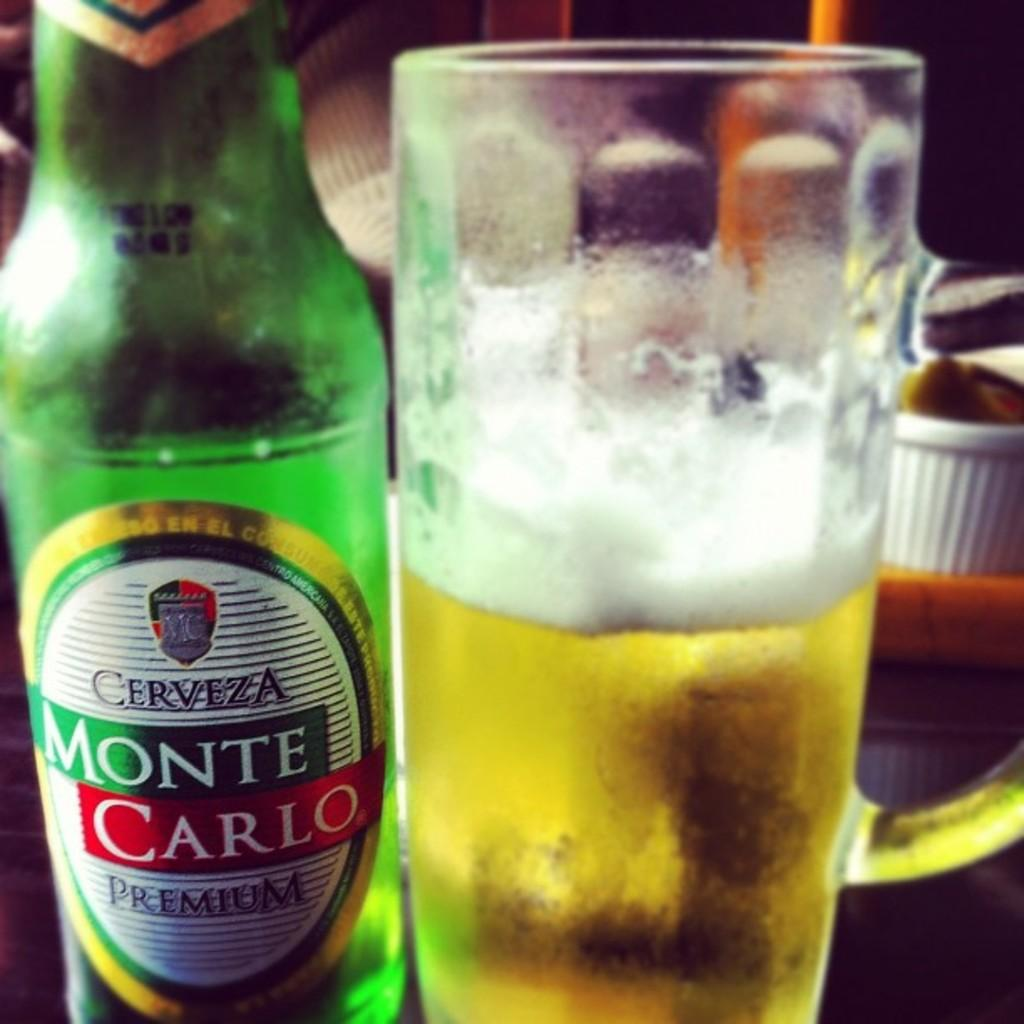<image>
Describe the image concisely. A bottle of Monte Carlo beer has been poured into a glass 